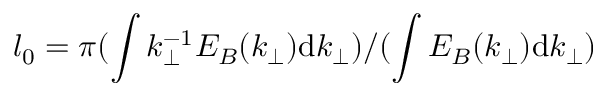<formula> <loc_0><loc_0><loc_500><loc_500>l _ { 0 } = \pi ( \int k _ { \perp } ^ { - 1 } E _ { B } ( k _ { \perp } ) d k _ { \perp } ) / ( \int E _ { B } ( k _ { \perp } ) d k _ { \perp } )</formula> 